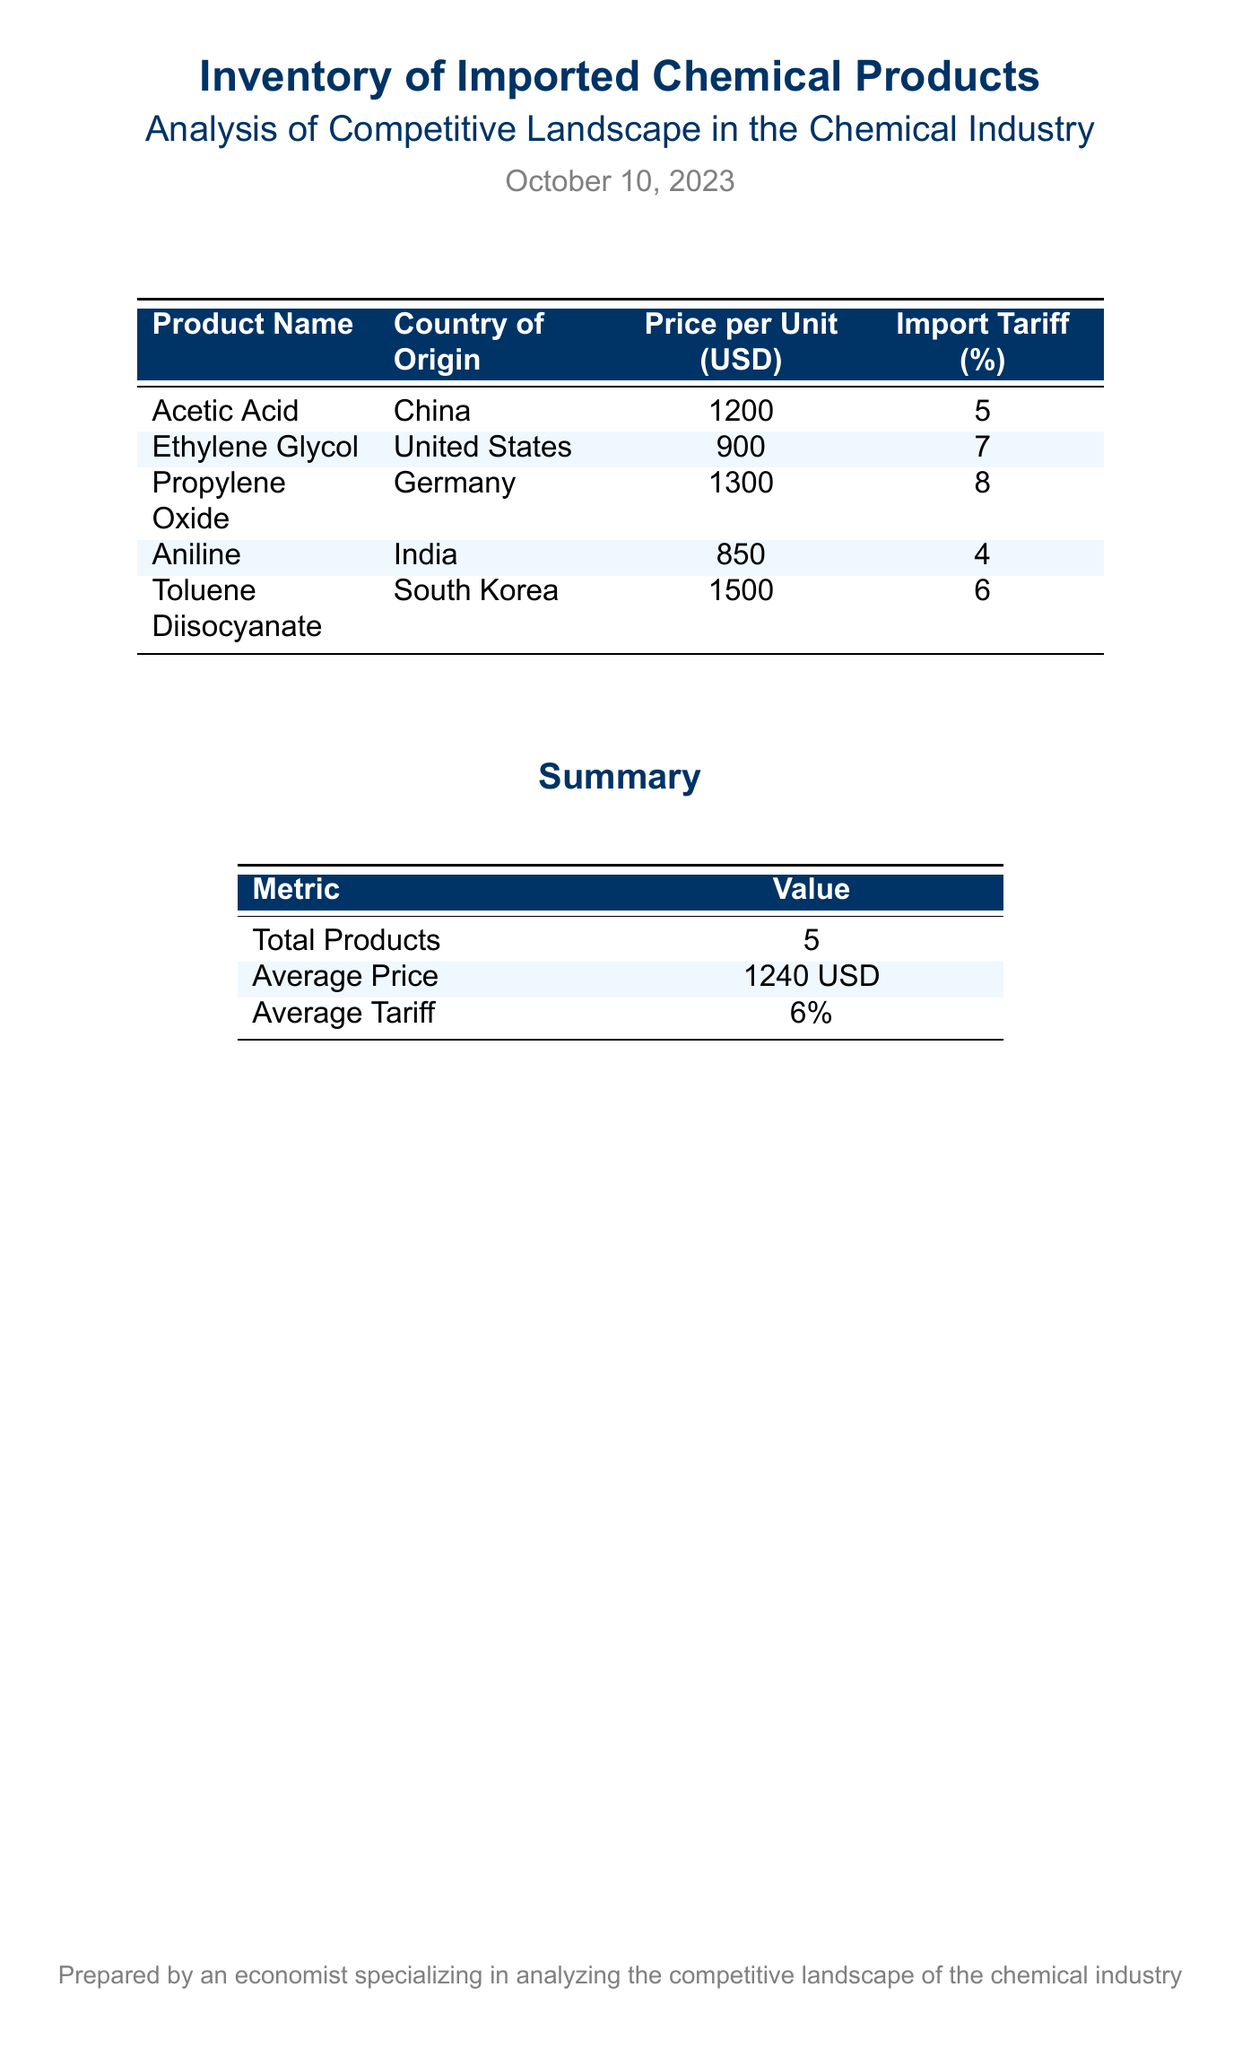What is the product name listed with the highest price? The product with the highest price in the document is Toluene Diisocyanate, which is priced at 1500 USD.
Answer: Toluene Diisocyanate What country does Aniline originate from? Aniline is listed in the document with India as its country of origin.
Answer: India What is the average price of the imported chemical products? The average price is calculated based on all products listed, resulting in an average of 1240 USD.
Answer: 1240 USD Which imported chemical product has the lowest import tariff? The document indicates that Aniline has the lowest import tariff at 4%.
Answer: 4% How many total products are listed in the inventory? The total number of products mentioned in the document is 5.
Answer: 5 What is the import tariff percentage for Propylene Oxide? The document states that the import tariff for Propylene Oxide is 8%.
Answer: 8% What is the summary's average tariff? The summary provides the average tariff value based on all products, which is 6%.
Answer: 6% How many products come from China? The document lists only one product, Acetic Acid, that originates from China.
Answer: 1 What metric is reported alongside the total products in the summary? The summary also reports the average price as a key metric alongside total products.
Answer: Average Price 